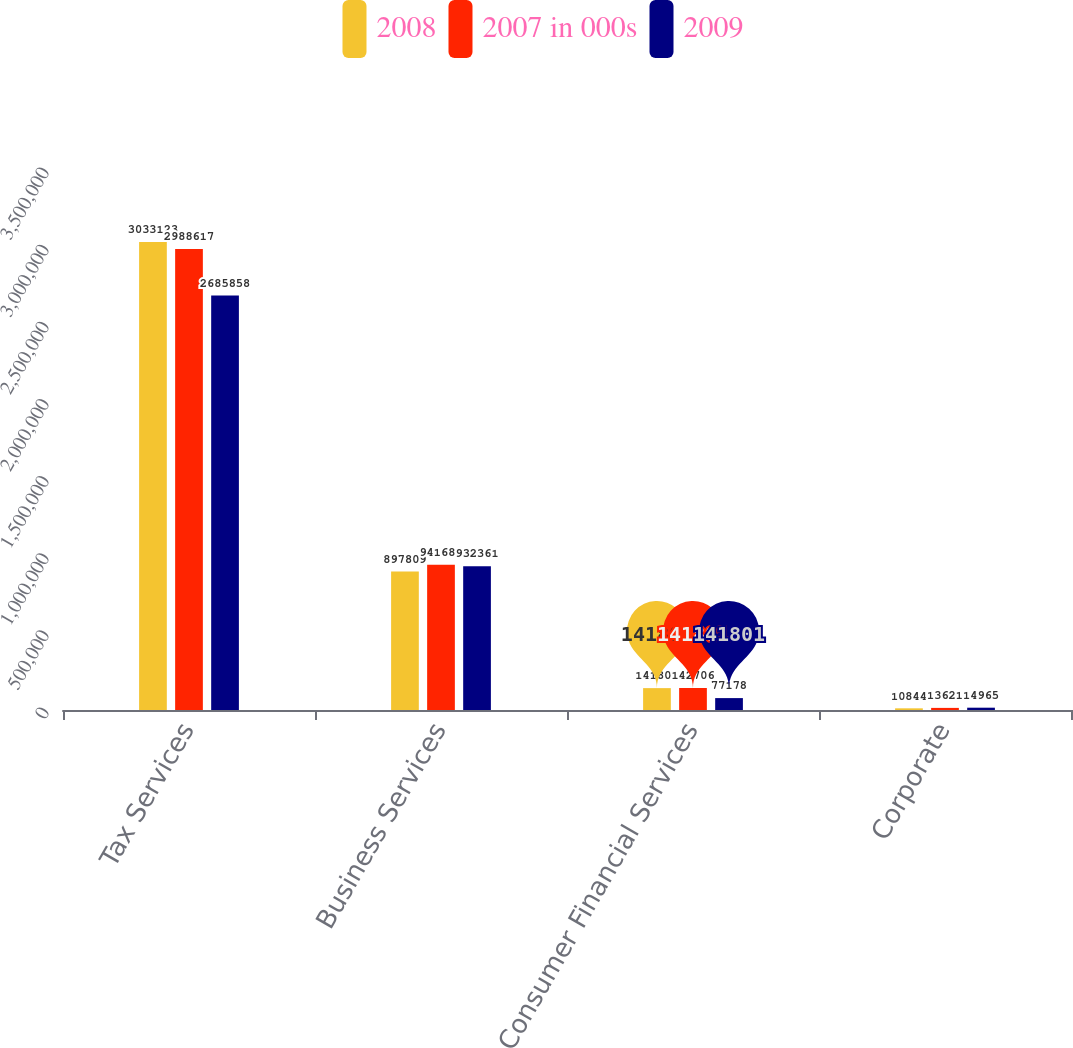Convert chart to OTSL. <chart><loc_0><loc_0><loc_500><loc_500><stacked_bar_chart><ecel><fcel>Tax Services<fcel>Business Services<fcel>Consumer Financial Services<fcel>Corporate<nl><fcel>2008<fcel>3.03312e+06<fcel>897809<fcel>141801<fcel>10844<nl><fcel>2007 in 000s<fcel>2.98862e+06<fcel>941686<fcel>142706<fcel>13621<nl><fcel>2009<fcel>2.68586e+06<fcel>932361<fcel>77178<fcel>14965<nl></chart> 